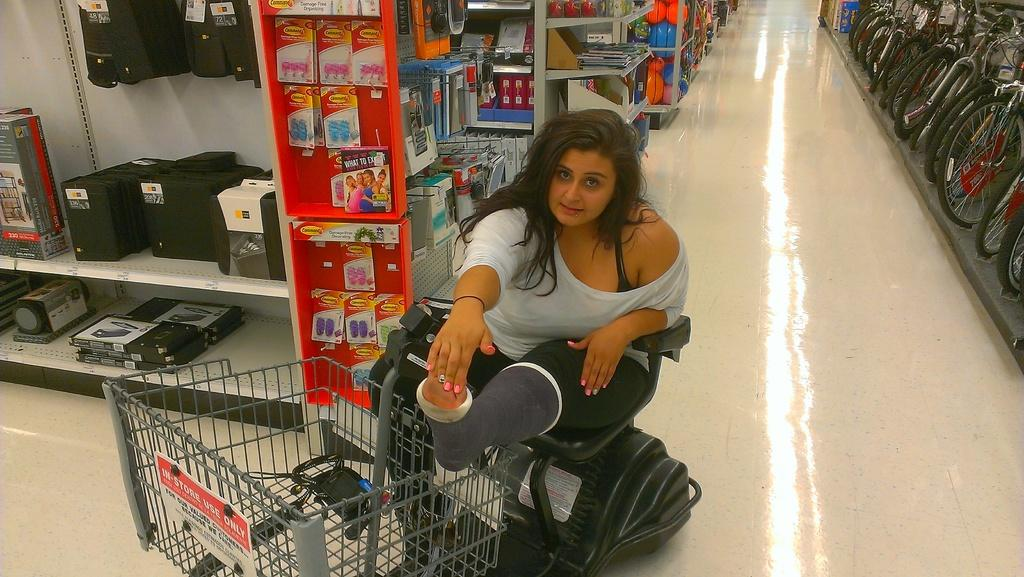What is the woman in the image using to move around? The woman is sitting on a wheelchair in the image. What type of object can be seen in the image that might be used for transporting items? There is a cart in the image that could be used for transporting items. What type of objects are present in the image that might be used for storage? There are boxes and racks in the image that could be used for storage. What type of objects are present in the image that might be used for transportation? There are bicycles in the image that could be used for transportation. What part of the environment can be seen in the image? The floor is visible in the image. How many planes are visible in the image? There are no planes visible in the image. What type of flight is the woman taking in the image? There is no flight or any indication of travel in the image. 